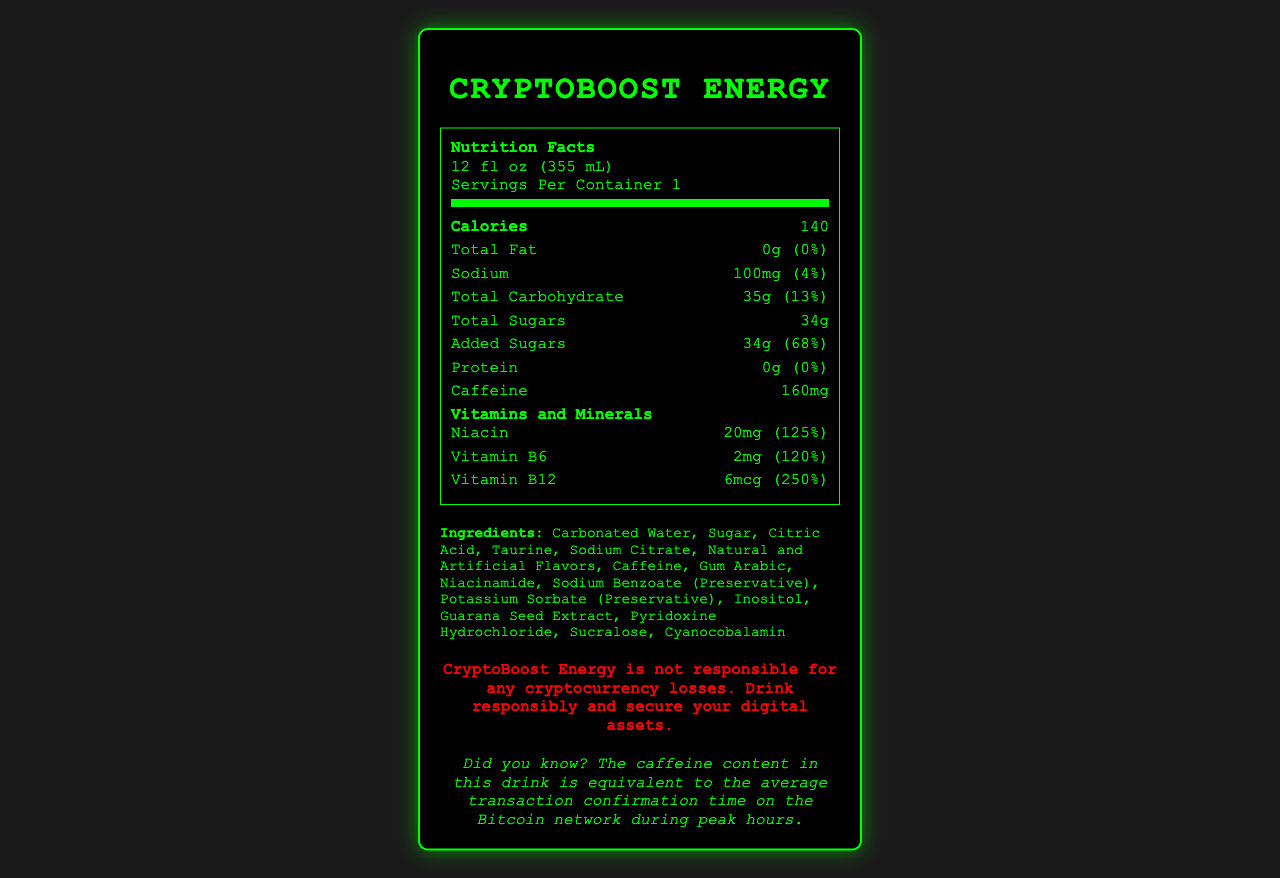what is the serving size of CryptoBoost Energy? The serving size is listed at the top of the nutrition label and states 12 fl oz (355 mL).
Answer: 12 fl oz (355 mL) what is the amount of caffeine in CryptoBoost Energy? The document lists the caffeine content as 160 mg.
Answer: 160 mg what is the percentage of daily value for added sugars in CryptoBoost Energy? The document shows 34g of added sugars, which is 68% of the daily value.
Answer: 68% what are the artificial ingredients in CryptoBoost Energy? The document specifically lists "Artificial Flavors" and "Sucralose" under artificial ingredients.
Answer: Artificial Flavors, Sucralose how much niacin is present in CryptoBoost Energy? The document includes 20 mg of Niacin, accounting for 125% of the daily value.
Answer: 20 mg (125% daily value) how many calories are in one serving of CryptoBoost Energy? The calories per serving are clearly stated as 140 in the nutrition label.
Answer: 140 calories how many servings per container does CryptoBoost Energy have? The nutrition label mentions that there is 1 serving per container.
Answer: 1 is there any protein in CryptoBoost Energy? Both the amount and daily value for protein are listed as 0g and 0%, respectively.
Answer: No how much sodium does CryptoBoost Energy contain? The document lists sodium content as 100 mg, which is 4% of the daily value.
Answer: 100 mg (4% daily value) how many vitamins and minerals are listed in the document? The document lists Niacin, Vitamin B6, and Vitamin B12 as part of the vitamins and minerals.
Answer: 3 which ingredient serves as a preservative in CryptoBoost Energy? A. Potassium Sorbate B. Citric Acid C. Taurine D. Gum Arabic The correct answer is Potassium Sorbate. The document lists it as a preservative.
Answer: A which vitamin has the highest daily value percentage in CryptoBoost Energy? I. Vitamin B6 II. Niacin III. Vitamin B12 Vitamin B12 has a daily value of 250%, the highest among the listed vitamins and minerals.
Answer: III does CryptoBoost Energy contain any natural flavors? The document does not specify any natural flavors under ingredients, only natural and artificial flavors are mentioned.
Answer: Cannot be determined summarize the nutritional breakdown, key ingredients, and security warning of CryptoBoost Energy. The product is designed as an energy drink with a high caffeine and sugar content, featuring several vitamins and a significant list of ingredients, emphasizing the need for responsible consumption, especially in the cryptocurrency context.
Answer: CryptoBoost Energy contains 140 calories per 12 fl oz serving and is high in caffeine (160 mg) and sugars (34g, 68% daily value). It includes vitamins such as Niacin (125%), Vitamin B6 (120%), and Vitamin B12 (250%). Key ingredients include carbonated water, sugar, citric acid, taurine, and caffeine, with artificial ingredients like artificial flavors and sucralose. The security warning advises responsibility in both drinking and securing digital assets. 